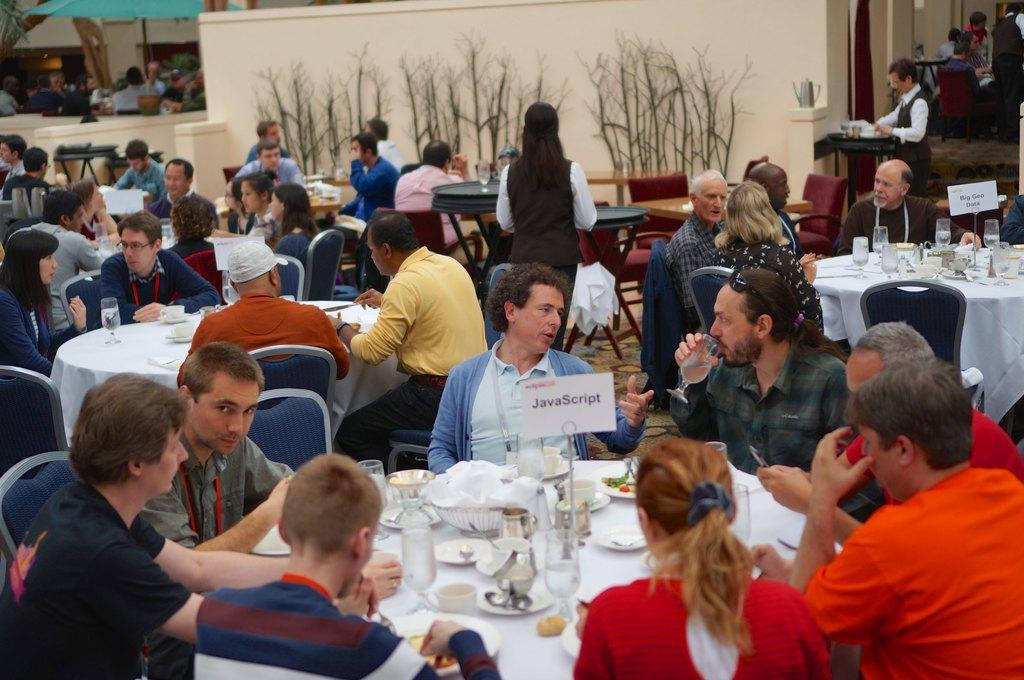How many people can be seen sitting in the image? There are many people sitting on chairs in the image. What type of furniture is present in the image? There are multiple chairs and tables in the image. What items can be found on the tables? There are glasses, wine glasses, tea cups, and spoons on the table. Can you see a pencil being used by anyone in the image? There is no pencil present in the image. Is there a loaf visible on any of the tables? There is no loaf present on any of the tables in the image. Is there a baby visible in the image? There is no baby present in the image. 